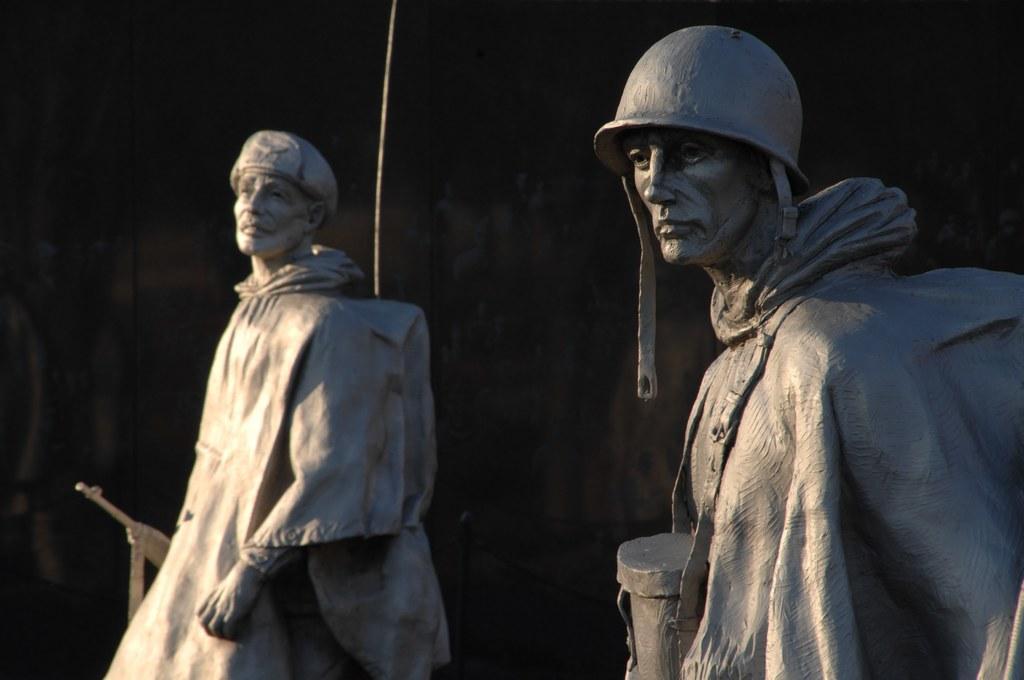How would you summarize this image in a sentence or two? In this picture I can see there are two statues and the backdrop is dark. 